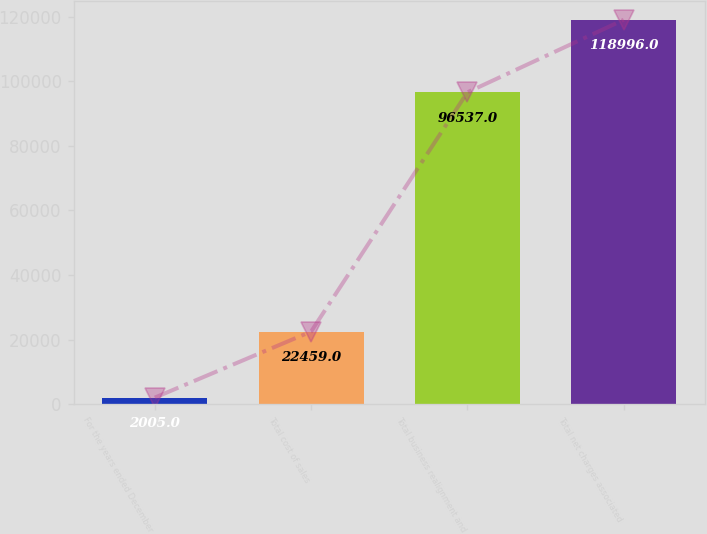<chart> <loc_0><loc_0><loc_500><loc_500><bar_chart><fcel>For the years ended December<fcel>Total cost of sales<fcel>Total business realignment and<fcel>Total net charges associated<nl><fcel>2005<fcel>22459<fcel>96537<fcel>118996<nl></chart> 